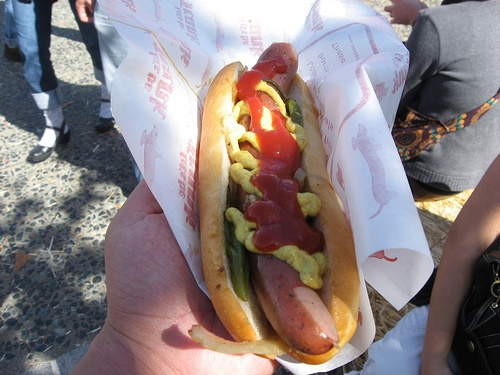Describe the objects in this image and their specific colors. I can see sandwich in darkgray, maroon, gray, and brown tones, hot dog in darkgray, maroon, gray, and brown tones, people in darkgray, black, and gray tones, people in darkgray, gray, lightpink, and maroon tones, and people in darkgray, brown, gray, and black tones in this image. 